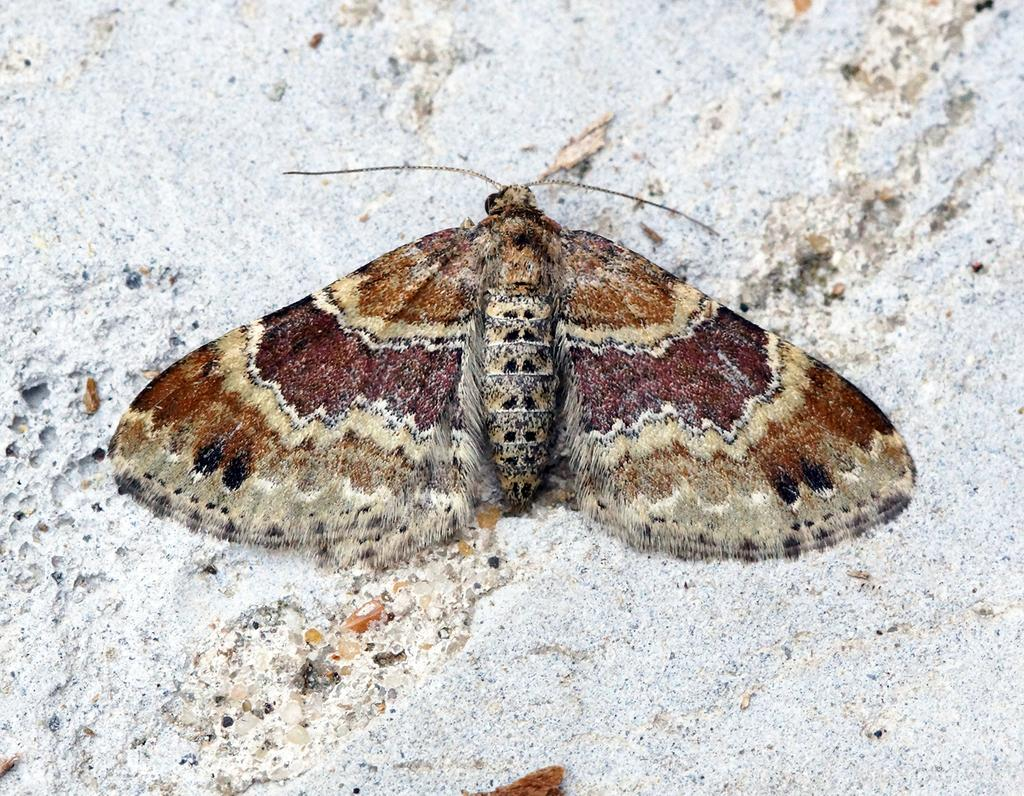What is the main subject of the image? There is a butterfly in the image. What is the color of the surface where the butterfly is resting? The butterfly is on a white-colored surface. How many teeth can be seen on the butterfly in the image? Butterflies do not have teeth, so there are no teeth visible on the butterfly in the image. 